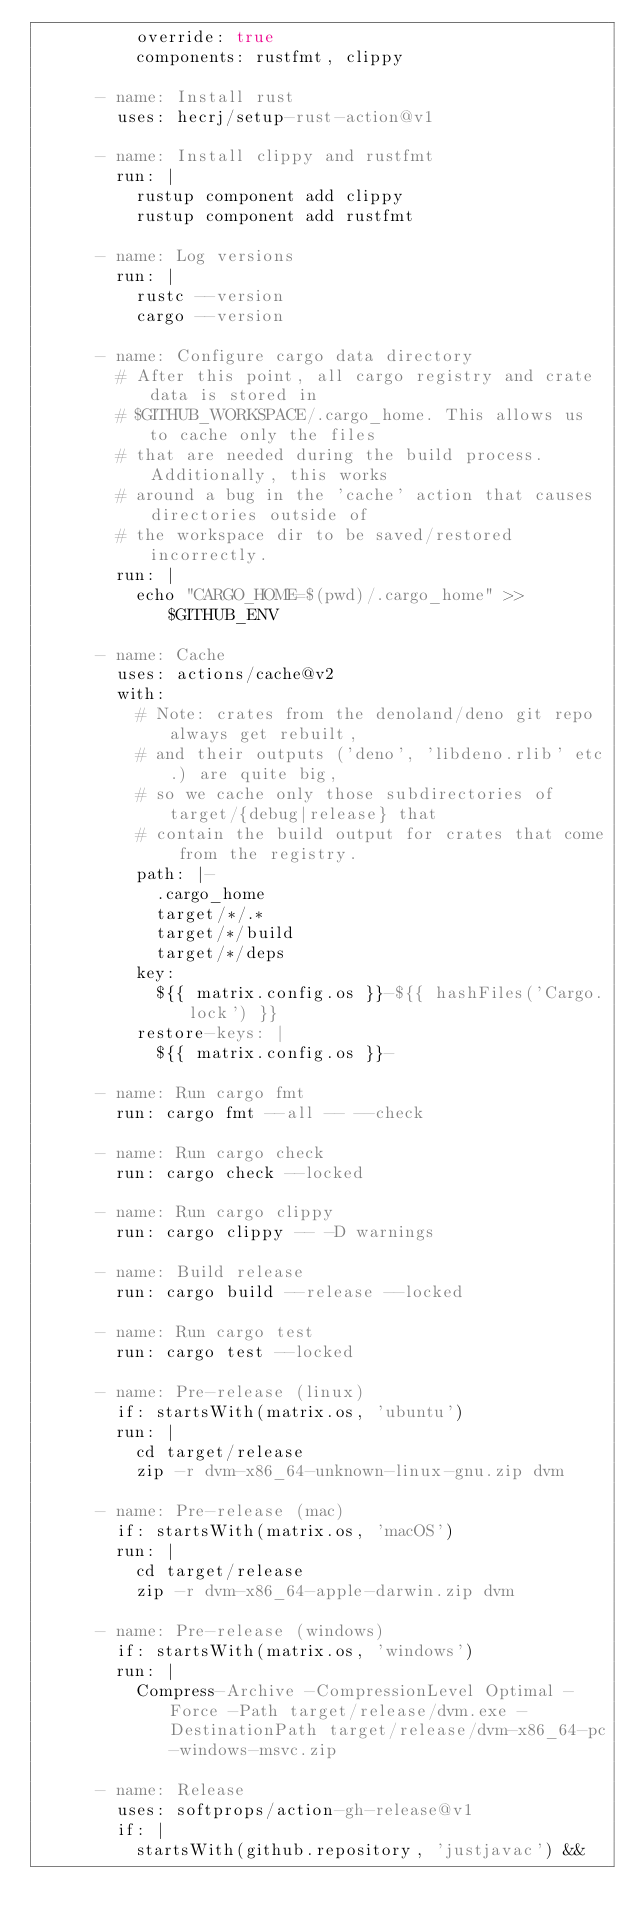<code> <loc_0><loc_0><loc_500><loc_500><_YAML_>          override: true
          components: rustfmt, clippy

      - name: Install rust
        uses: hecrj/setup-rust-action@v1

      - name: Install clippy and rustfmt
        run: |
          rustup component add clippy
          rustup component add rustfmt

      - name: Log versions
        run: |
          rustc --version
          cargo --version

      - name: Configure cargo data directory
        # After this point, all cargo registry and crate data is stored in
        # $GITHUB_WORKSPACE/.cargo_home. This allows us to cache only the files
        # that are needed during the build process. Additionally, this works
        # around a bug in the 'cache' action that causes directories outside of
        # the workspace dir to be saved/restored incorrectly.
        run: |
          echo "CARGO_HOME=$(pwd)/.cargo_home" >> $GITHUB_ENV

      - name: Cache
        uses: actions/cache@v2
        with:
          # Note: crates from the denoland/deno git repo always get rebuilt,
          # and their outputs ('deno', 'libdeno.rlib' etc.) are quite big,
          # so we cache only those subdirectories of target/{debug|release} that
          # contain the build output for crates that come from the registry.
          path: |-
            .cargo_home
            target/*/.*
            target/*/build
            target/*/deps
          key:
            ${{ matrix.config.os }}-${{ hashFiles('Cargo.lock') }}
          restore-keys: |
            ${{ matrix.config.os }}-

      - name: Run cargo fmt
        run: cargo fmt --all -- --check

      - name: Run cargo check
        run: cargo check --locked

      - name: Run cargo clippy
        run: cargo clippy -- -D warnings

      - name: Build release
        run: cargo build --release --locked

      - name: Run cargo test
        run: cargo test --locked

      - name: Pre-release (linux)
        if: startsWith(matrix.os, 'ubuntu')
        run: |
          cd target/release
          zip -r dvm-x86_64-unknown-linux-gnu.zip dvm

      - name: Pre-release (mac)
        if: startsWith(matrix.os, 'macOS')
        run: |
          cd target/release
          zip -r dvm-x86_64-apple-darwin.zip dvm

      - name: Pre-release (windows)
        if: startsWith(matrix.os, 'windows')
        run: |
          Compress-Archive -CompressionLevel Optimal -Force -Path target/release/dvm.exe -DestinationPath target/release/dvm-x86_64-pc-windows-msvc.zip

      - name: Release
        uses: softprops/action-gh-release@v1
        if: |
          startsWith(github.repository, 'justjavac') &&</code> 